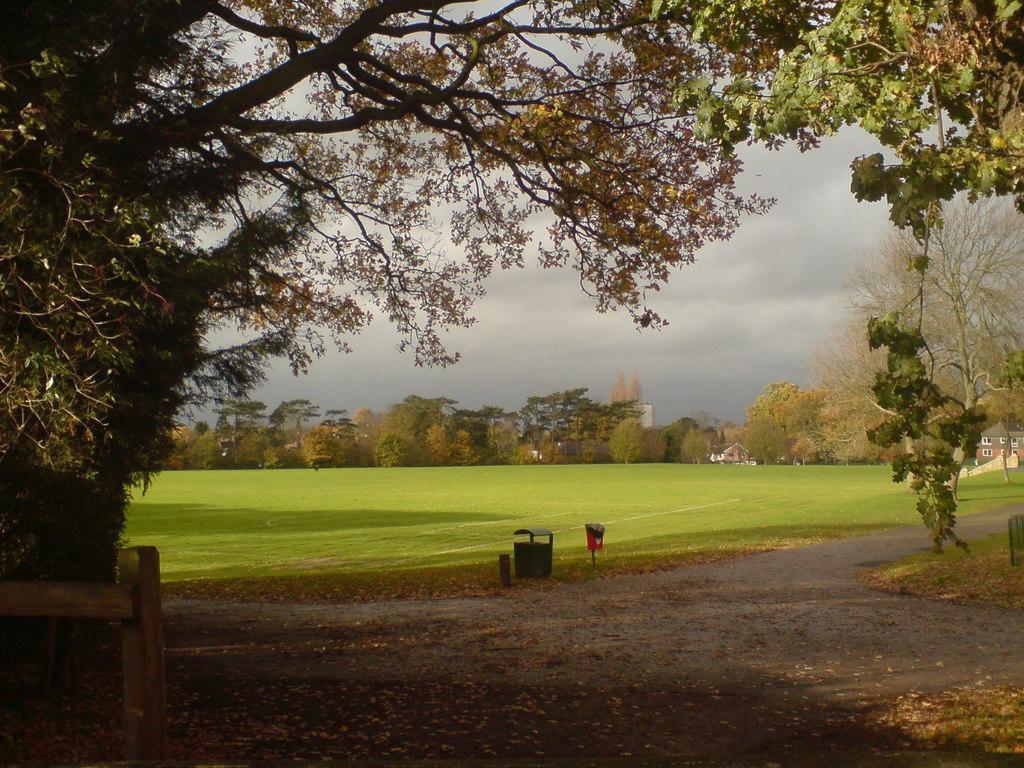How would you summarize this image in a sentence or two? There are dustbins in the center of the image and there is a wooden boundary on the left side. There are trees, grassland, houses and sky in the background area. 